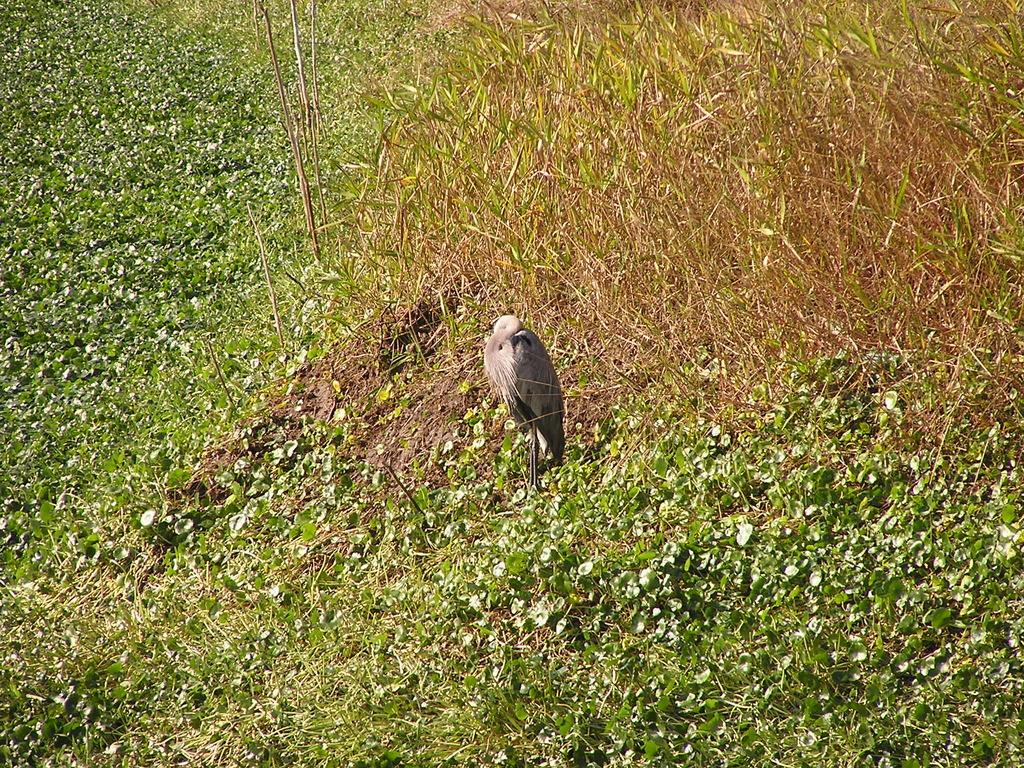What type of animal is in the picture? There is a bird in the picture. What is the bird doing in the picture? The bird is standing. What can be seen in the background around the bird? There are leaves and plants around the bird. What colors are the bird's feathers? The bird has black and grey feathers. What type of stove can be seen in the picture? There is no stove present in the picture; it features a bird standing among leaves and plants. What things are falling from the sky during the rainstorm in the picture? There is no rainstorm present in the picture, so it is not possible to determine what things might be falling from the sky. 